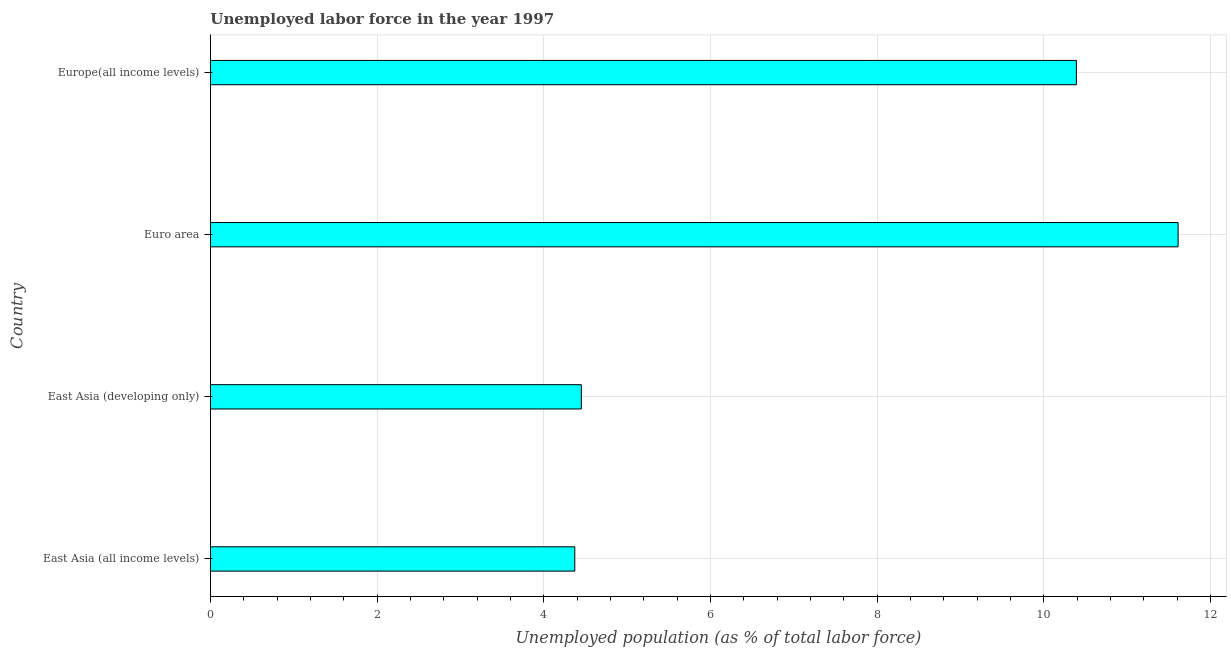What is the title of the graph?
Offer a very short reply. Unemployed labor force in the year 1997. What is the label or title of the X-axis?
Your answer should be very brief. Unemployed population (as % of total labor force). What is the label or title of the Y-axis?
Keep it short and to the point. Country. What is the total unemployed population in Euro area?
Ensure brevity in your answer.  11.61. Across all countries, what is the maximum total unemployed population?
Ensure brevity in your answer.  11.61. Across all countries, what is the minimum total unemployed population?
Your answer should be compact. 4.37. In which country was the total unemployed population minimum?
Make the answer very short. East Asia (all income levels). What is the sum of the total unemployed population?
Make the answer very short. 30.82. What is the difference between the total unemployed population in East Asia (all income levels) and Euro area?
Give a very brief answer. -7.24. What is the average total unemployed population per country?
Give a very brief answer. 7.71. What is the median total unemployed population?
Your response must be concise. 7.42. In how many countries, is the total unemployed population greater than 7.6 %?
Make the answer very short. 2. What is the ratio of the total unemployed population in East Asia (all income levels) to that in Euro area?
Provide a short and direct response. 0.38. What is the difference between the highest and the second highest total unemployed population?
Make the answer very short. 1.22. What is the difference between the highest and the lowest total unemployed population?
Provide a succinct answer. 7.24. In how many countries, is the total unemployed population greater than the average total unemployed population taken over all countries?
Make the answer very short. 2. How many bars are there?
Ensure brevity in your answer.  4. Are all the bars in the graph horizontal?
Offer a very short reply. Yes. What is the difference between two consecutive major ticks on the X-axis?
Make the answer very short. 2. Are the values on the major ticks of X-axis written in scientific E-notation?
Your response must be concise. No. What is the Unemployed population (as % of total labor force) of East Asia (all income levels)?
Provide a short and direct response. 4.37. What is the Unemployed population (as % of total labor force) of East Asia (developing only)?
Ensure brevity in your answer.  4.45. What is the Unemployed population (as % of total labor force) in Euro area?
Make the answer very short. 11.61. What is the Unemployed population (as % of total labor force) in Europe(all income levels)?
Offer a terse response. 10.39. What is the difference between the Unemployed population (as % of total labor force) in East Asia (all income levels) and East Asia (developing only)?
Give a very brief answer. -0.08. What is the difference between the Unemployed population (as % of total labor force) in East Asia (all income levels) and Euro area?
Provide a short and direct response. -7.24. What is the difference between the Unemployed population (as % of total labor force) in East Asia (all income levels) and Europe(all income levels)?
Your answer should be very brief. -6.02. What is the difference between the Unemployed population (as % of total labor force) in East Asia (developing only) and Euro area?
Offer a very short reply. -7.16. What is the difference between the Unemployed population (as % of total labor force) in East Asia (developing only) and Europe(all income levels)?
Offer a very short reply. -5.94. What is the difference between the Unemployed population (as % of total labor force) in Euro area and Europe(all income levels)?
Your answer should be compact. 1.22. What is the ratio of the Unemployed population (as % of total labor force) in East Asia (all income levels) to that in East Asia (developing only)?
Give a very brief answer. 0.98. What is the ratio of the Unemployed population (as % of total labor force) in East Asia (all income levels) to that in Euro area?
Your answer should be very brief. 0.38. What is the ratio of the Unemployed population (as % of total labor force) in East Asia (all income levels) to that in Europe(all income levels)?
Provide a short and direct response. 0.42. What is the ratio of the Unemployed population (as % of total labor force) in East Asia (developing only) to that in Euro area?
Your answer should be compact. 0.38. What is the ratio of the Unemployed population (as % of total labor force) in East Asia (developing only) to that in Europe(all income levels)?
Your answer should be very brief. 0.43. What is the ratio of the Unemployed population (as % of total labor force) in Euro area to that in Europe(all income levels)?
Provide a succinct answer. 1.12. 